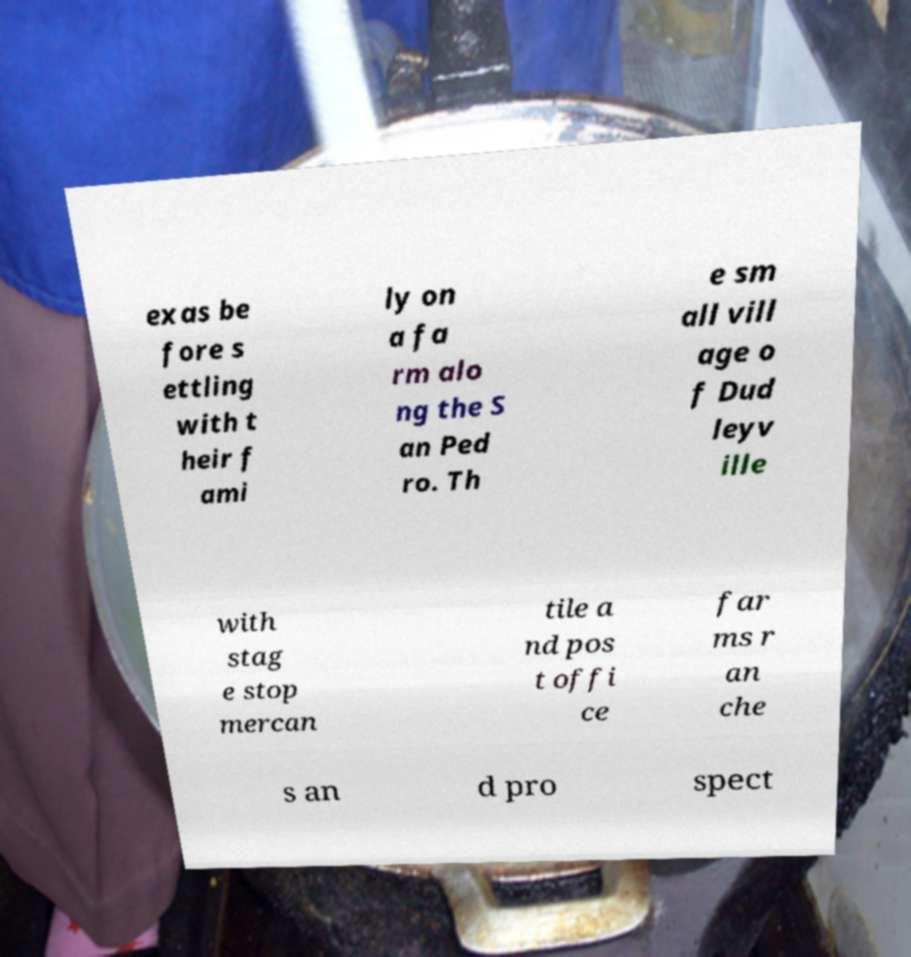Can you accurately transcribe the text from the provided image for me? exas be fore s ettling with t heir f ami ly on a fa rm alo ng the S an Ped ro. Th e sm all vill age o f Dud leyv ille with stag e stop mercan tile a nd pos t offi ce far ms r an che s an d pro spect 